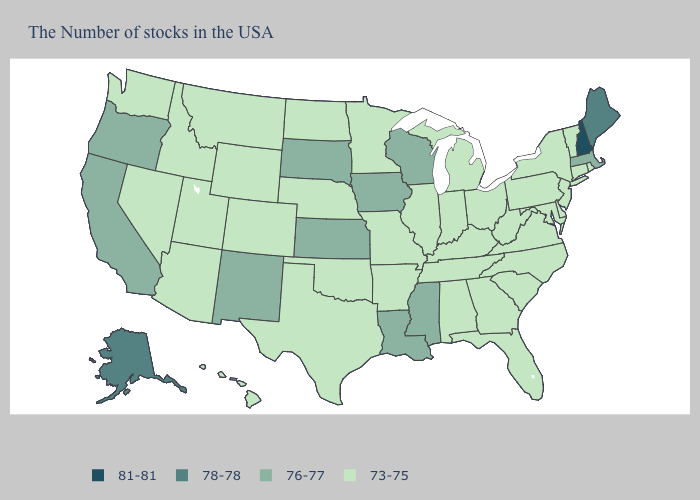What is the value of New York?
Quick response, please. 73-75. Does Alaska have the highest value in the West?
Be succinct. Yes. What is the highest value in the MidWest ?
Keep it brief. 76-77. Does Hawaii have the same value as Wisconsin?
Give a very brief answer. No. Name the states that have a value in the range 76-77?
Keep it brief. Massachusetts, Wisconsin, Mississippi, Louisiana, Iowa, Kansas, South Dakota, New Mexico, California, Oregon. What is the value of West Virginia?
Short answer required. 73-75. What is the value of Montana?
Keep it brief. 73-75. Does the map have missing data?
Give a very brief answer. No. Which states have the lowest value in the USA?
Quick response, please. Rhode Island, Vermont, Connecticut, New York, New Jersey, Delaware, Maryland, Pennsylvania, Virginia, North Carolina, South Carolina, West Virginia, Ohio, Florida, Georgia, Michigan, Kentucky, Indiana, Alabama, Tennessee, Illinois, Missouri, Arkansas, Minnesota, Nebraska, Oklahoma, Texas, North Dakota, Wyoming, Colorado, Utah, Montana, Arizona, Idaho, Nevada, Washington, Hawaii. What is the highest value in states that border Ohio?
Answer briefly. 73-75. Name the states that have a value in the range 73-75?
Keep it brief. Rhode Island, Vermont, Connecticut, New York, New Jersey, Delaware, Maryland, Pennsylvania, Virginia, North Carolina, South Carolina, West Virginia, Ohio, Florida, Georgia, Michigan, Kentucky, Indiana, Alabama, Tennessee, Illinois, Missouri, Arkansas, Minnesota, Nebraska, Oklahoma, Texas, North Dakota, Wyoming, Colorado, Utah, Montana, Arizona, Idaho, Nevada, Washington, Hawaii. What is the value of Rhode Island?
Short answer required. 73-75. Does Maryland have the highest value in the USA?
Concise answer only. No. What is the value of Delaware?
Write a very short answer. 73-75. Name the states that have a value in the range 76-77?
Be succinct. Massachusetts, Wisconsin, Mississippi, Louisiana, Iowa, Kansas, South Dakota, New Mexico, California, Oregon. 